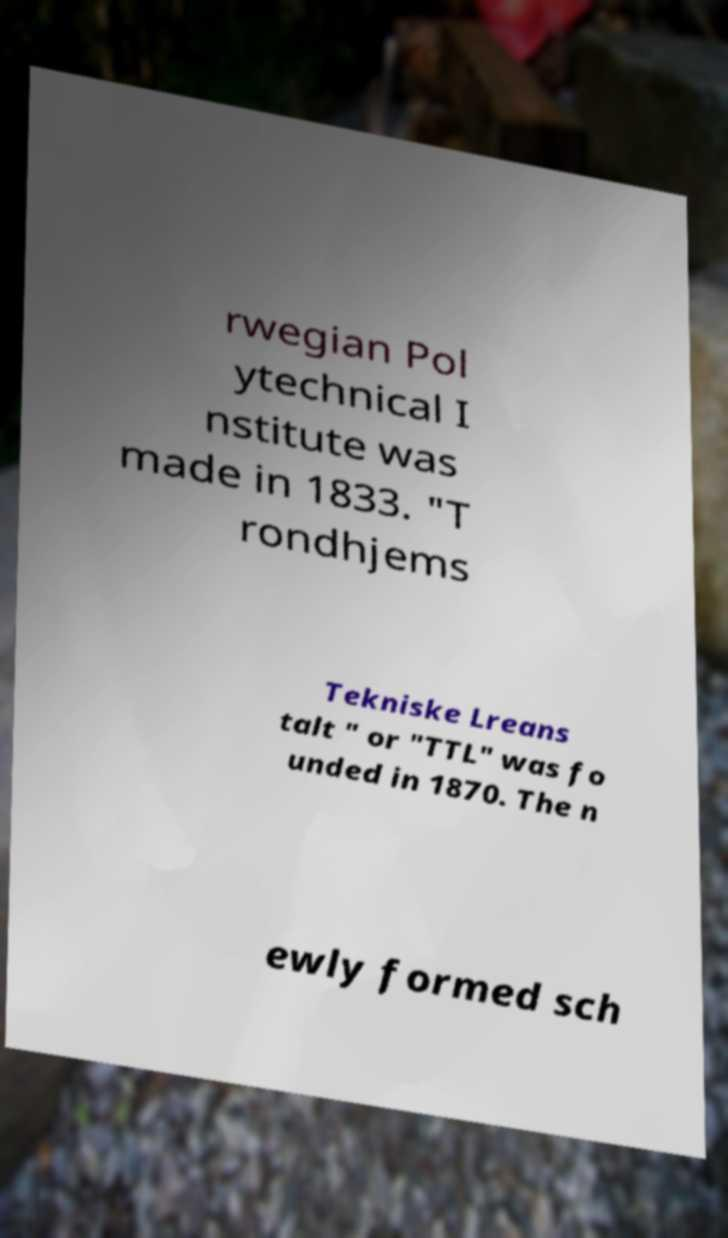Can you read and provide the text displayed in the image?This photo seems to have some interesting text. Can you extract and type it out for me? rwegian Pol ytechnical I nstitute was made in 1833. "T rondhjems Tekniske Lreans talt " or "TTL" was fo unded in 1870. The n ewly formed sch 